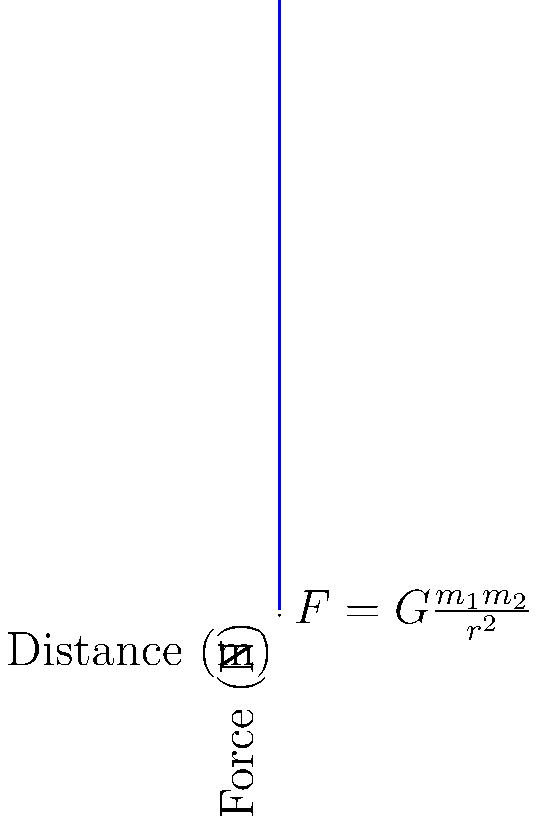During your church's astronomy night, you're explaining gravitational forces to a group of children. You use the example of two celestial bodies: one with a mass of $5 \times 10^{24}$ kg (similar to Earth) and another with a mass of $1 \times 10^{24}$ kg. If the gravitational force between them is $2 \times 10^{18}$ N when they are $5 \times 10^7$ m apart, what would the force be if the distance between them doubled? Let's approach this step-by-step:

1) First, recall Newton's law of universal gravitation:
   $F = G\frac{m_1m_2}{r^2}$

   Where:
   $F$ is the gravitational force
   $G$ is the gravitational constant ($6.67 \times 10^{-11}$ N⋅m²/kg²)
   $m_1$ and $m_2$ are the masses of the two bodies
   $r$ is the distance between their centers

2) We're given that initially:
   $F_1 = 2 \times 10^{18}$ N
   $r_1 = 5 \times 10^7$ m
   $m_1 = 5 \times 10^{24}$ kg
   $m_2 = 1 \times 10^{24}$ kg

3) When the distance doubles, $r_2 = 2r_1 = 10 \times 10^7$ m

4) The new force $F_2$ can be calculated using the inverse square relationship:
   $\frac{F_2}{F_1} = (\frac{r_1}{r_2})^2$

5) Rearranging this equation:
   $F_2 = F_1 \times (\frac{r_1}{r_2})^2$

6) Substituting the values:
   $F_2 = 2 \times 10^{18} \times (\frac{5 \times 10^7}{10 \times 10^7})^2$
   
7) Simplifying:
   $F_2 = 2 \times 10^{18} \times (\frac{1}{2})^2 = 2 \times 10^{18} \times \frac{1}{4} = 5 \times 10^{17}$ N

Therefore, when the distance doubles, the gravitational force reduces to one-fourth of its original value.
Answer: $5 \times 10^{17}$ N 